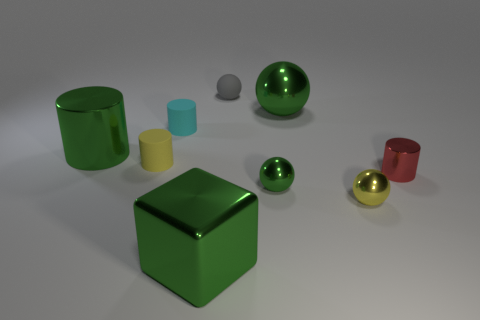There is a metallic cylinder that is to the right of the tiny matte ball; what number of large metal balls are to the right of it?
Keep it short and to the point. 0. There is a cylinder that is the same color as the large shiny block; what size is it?
Provide a short and direct response. Large. What number of objects are large blue matte cubes or big shiny objects on the right side of the large green metallic cube?
Keep it short and to the point. 1. Is there a big cyan object that has the same material as the yellow cylinder?
Ensure brevity in your answer.  No. How many objects are both behind the green block and in front of the tiny gray object?
Give a very brief answer. 7. There is a green sphere in front of the small cyan thing; what material is it?
Give a very brief answer. Metal. There is a yellow sphere that is made of the same material as the large cylinder; what size is it?
Ensure brevity in your answer.  Small. Are there any small green things on the right side of the yellow matte cylinder?
Your response must be concise. Yes. There is a cyan thing that is the same shape as the red metallic object; what size is it?
Give a very brief answer. Small. Does the large metal cylinder have the same color as the big metallic thing that is in front of the large green metal cylinder?
Your answer should be very brief. Yes. 